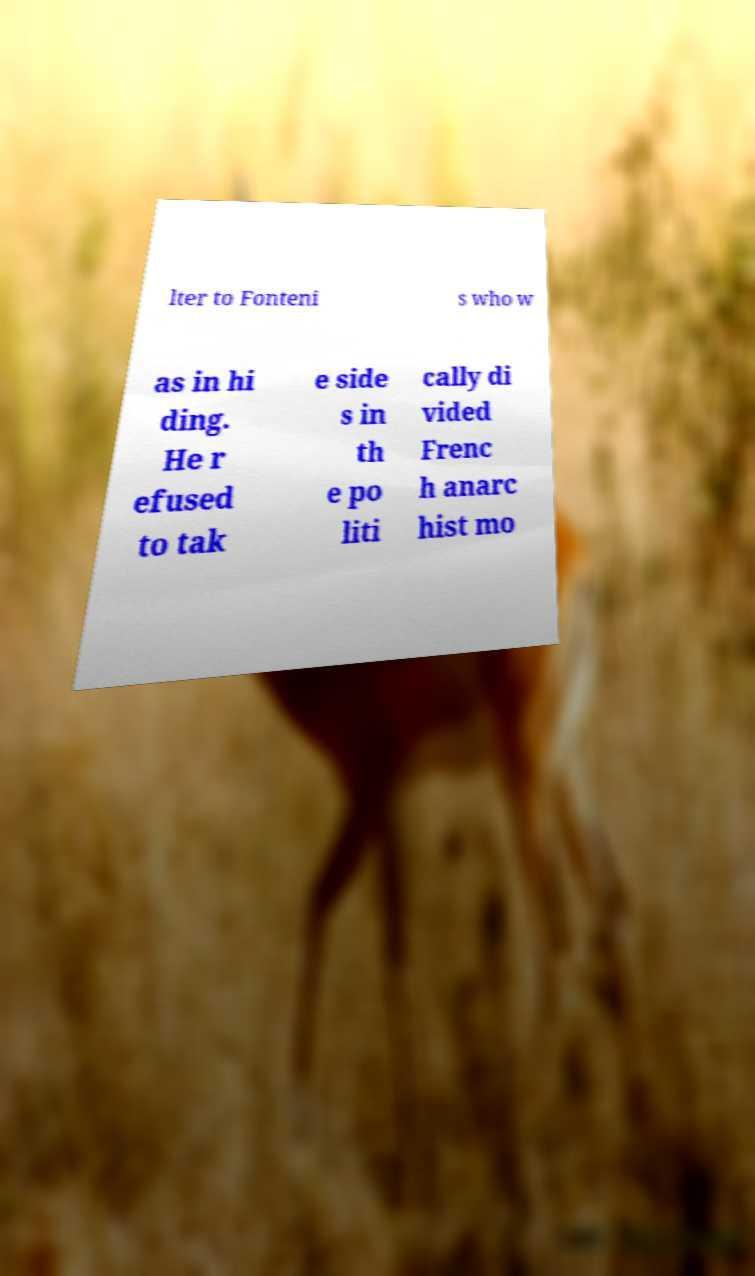Could you extract and type out the text from this image? lter to Fonteni s who w as in hi ding. He r efused to tak e side s in th e po liti cally di vided Frenc h anarc hist mo 